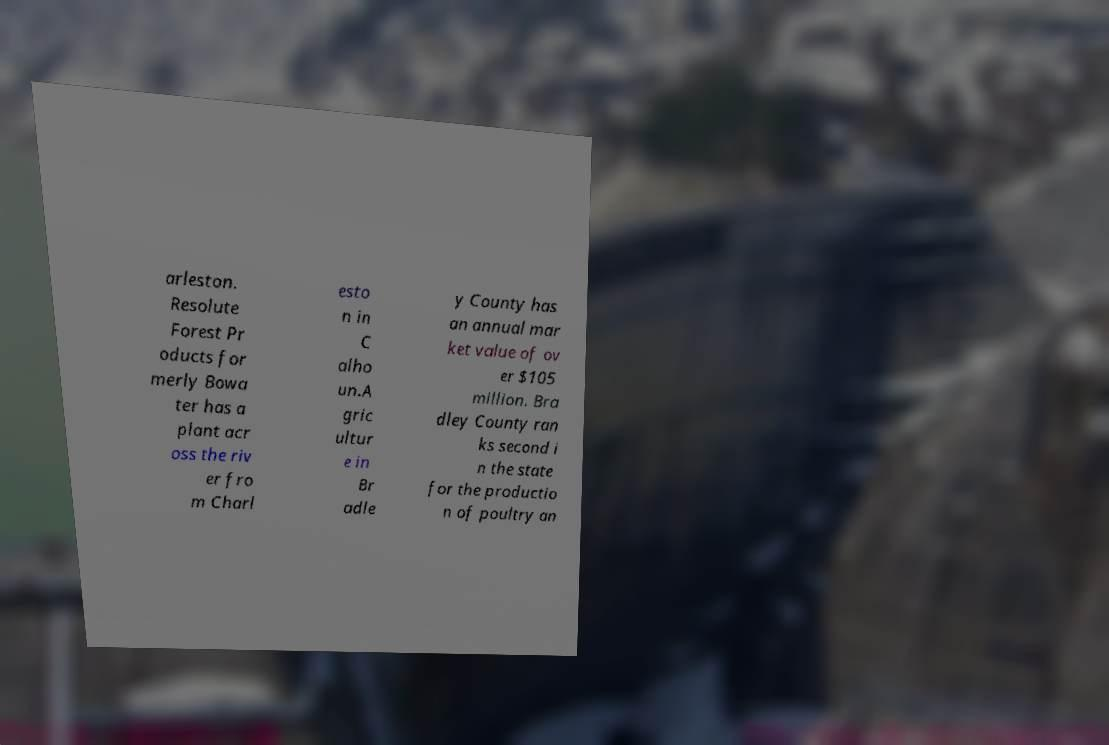For documentation purposes, I need the text within this image transcribed. Could you provide that? arleston. Resolute Forest Pr oducts for merly Bowa ter has a plant acr oss the riv er fro m Charl esto n in C alho un.A gric ultur e in Br adle y County has an annual mar ket value of ov er $105 million. Bra dley County ran ks second i n the state for the productio n of poultry an 